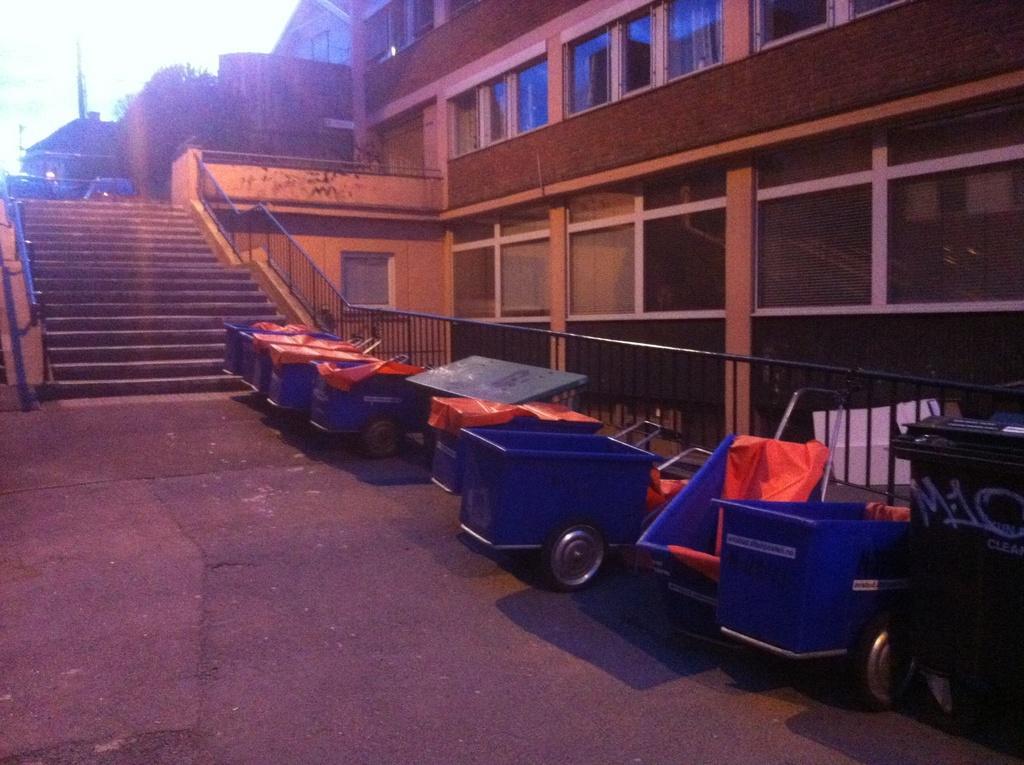How would you summarize this image in a sentence or two? In the picture we can see a building with glass windows and beside it we can see stairs with railings on both the sides of the steps and on the top of it we can see some plants and sky and near the steps we can see a path with some carts which are blue in color with wheels and handle. 